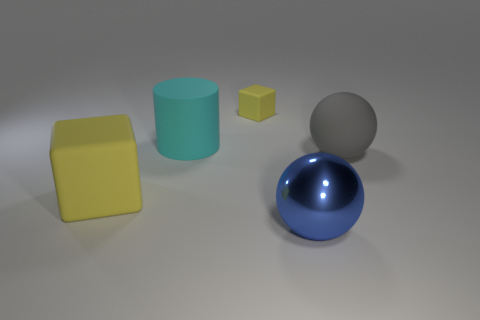What might be the function of these objects if they were not just models? If these objects were not models, the cubes could serve as storage containers or seats, the cylinder might be a base for a standing object or a simplistic stool, and the spheres could be decorative or functional orbs, possibly serving as part of a machinery or as design elements in a playground. 